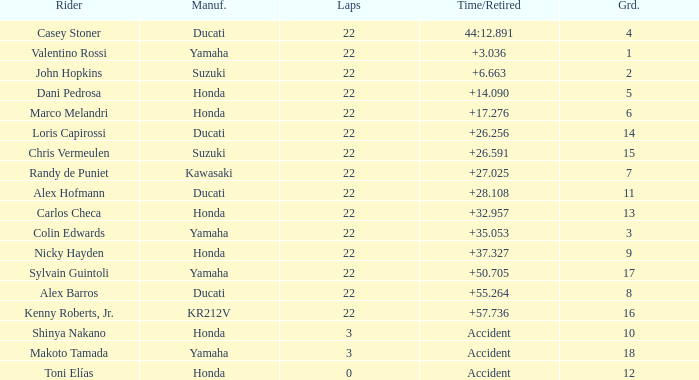What is the average grid for the competitiors who had laps smaller than 3? 12.0. 